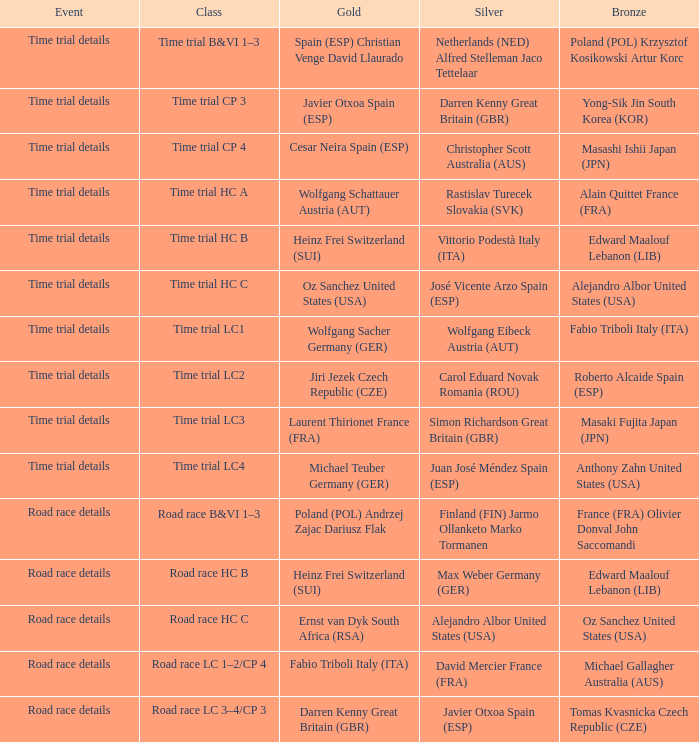Who received gold when silver is wolfgang eibeck austria (aut)? Wolfgang Sacher Germany (GER). 